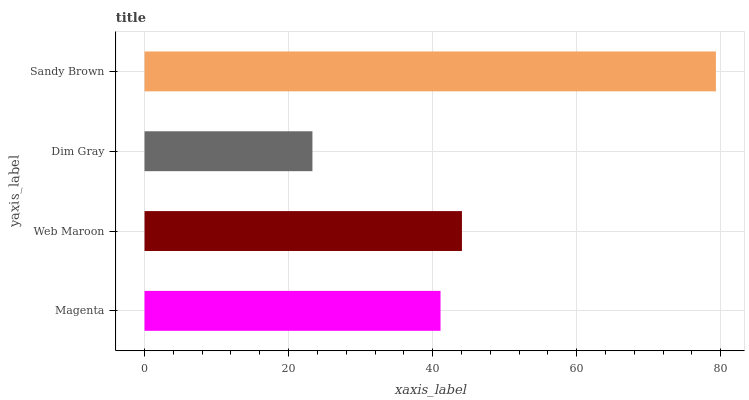Is Dim Gray the minimum?
Answer yes or no. Yes. Is Sandy Brown the maximum?
Answer yes or no. Yes. Is Web Maroon the minimum?
Answer yes or no. No. Is Web Maroon the maximum?
Answer yes or no. No. Is Web Maroon greater than Magenta?
Answer yes or no. Yes. Is Magenta less than Web Maroon?
Answer yes or no. Yes. Is Magenta greater than Web Maroon?
Answer yes or no. No. Is Web Maroon less than Magenta?
Answer yes or no. No. Is Web Maroon the high median?
Answer yes or no. Yes. Is Magenta the low median?
Answer yes or no. Yes. Is Sandy Brown the high median?
Answer yes or no. No. Is Dim Gray the low median?
Answer yes or no. No. 